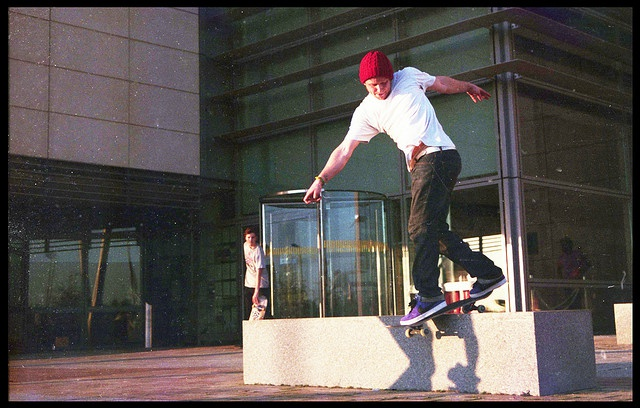Describe the objects in this image and their specific colors. I can see people in black, white, gray, and brown tones, people in black, ivory, gray, and lightpink tones, skateboard in black, gray, and white tones, people in black and gray tones, and skateboard in black, ivory, lightpink, tan, and gray tones in this image. 